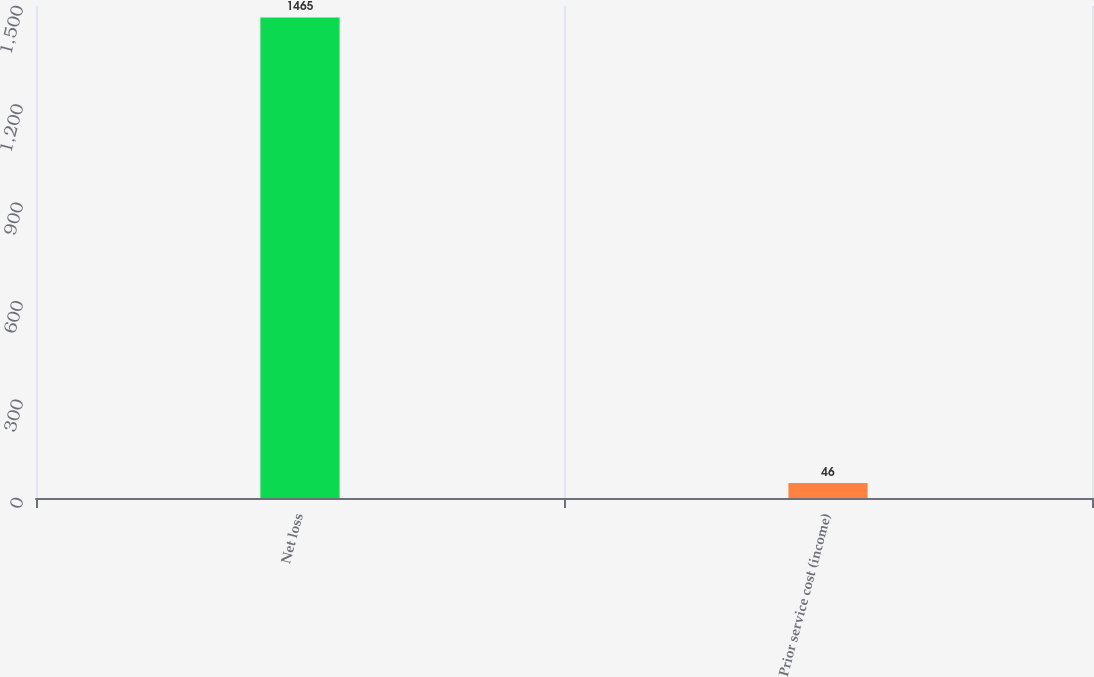<chart> <loc_0><loc_0><loc_500><loc_500><bar_chart><fcel>Net loss<fcel>Prior service cost (income)<nl><fcel>1465<fcel>46<nl></chart> 